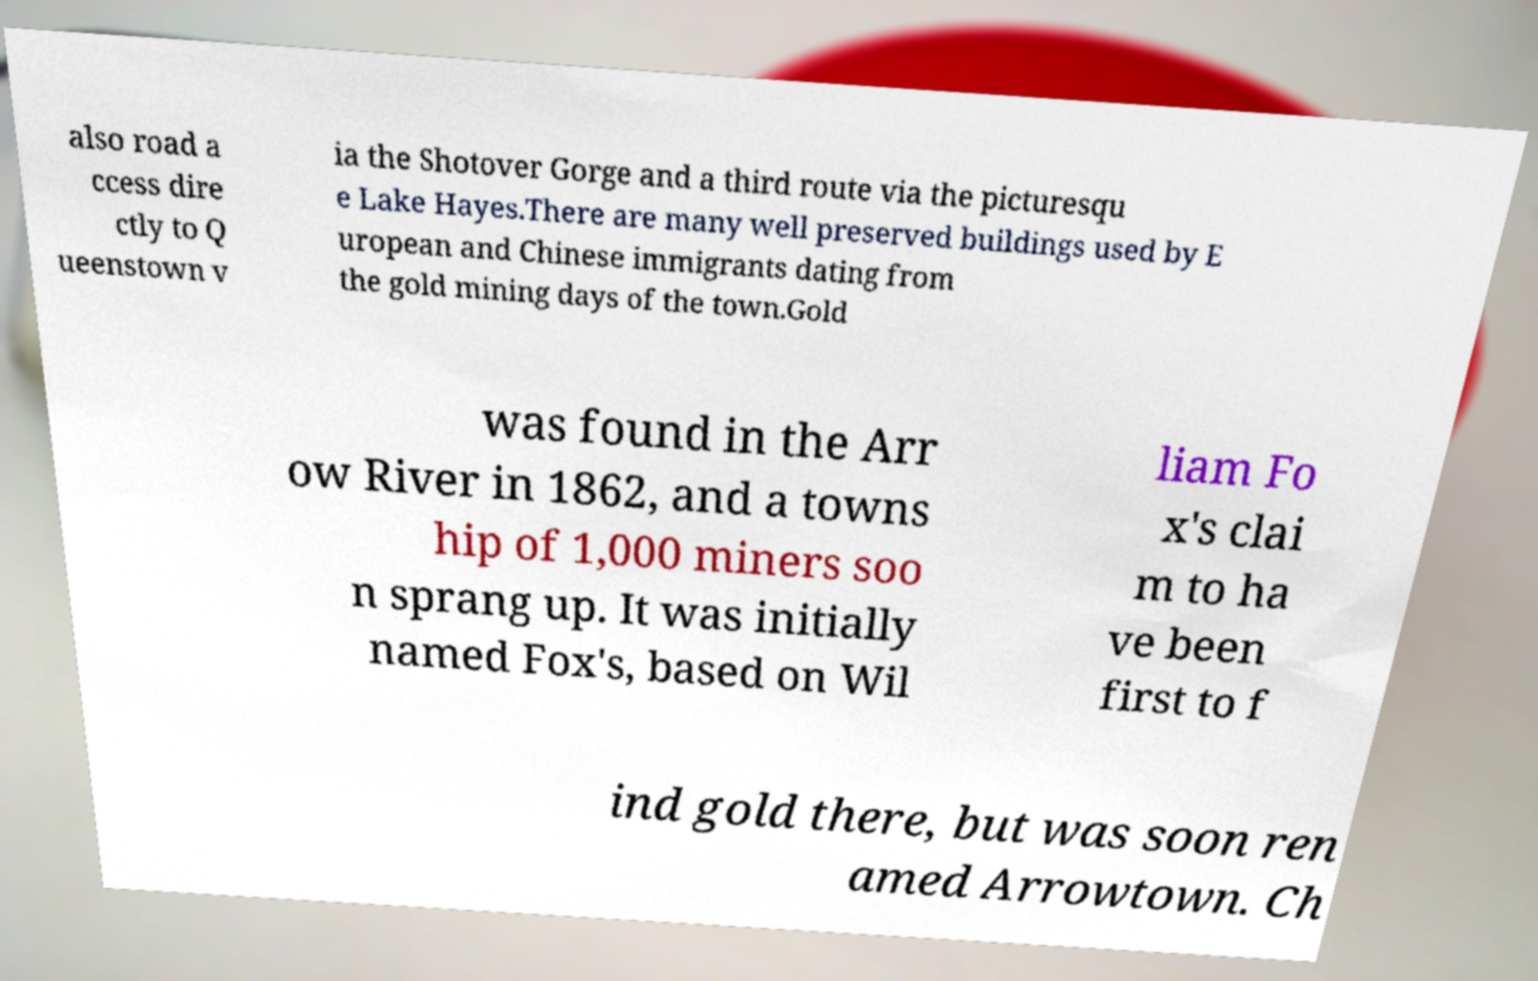Please read and relay the text visible in this image. What does it say? also road a ccess dire ctly to Q ueenstown v ia the Shotover Gorge and a third route via the picturesqu e Lake Hayes.There are many well preserved buildings used by E uropean and Chinese immigrants dating from the gold mining days of the town.Gold was found in the Arr ow River in 1862, and a towns hip of 1,000 miners soo n sprang up. It was initially named Fox's, based on Wil liam Fo x's clai m to ha ve been first to f ind gold there, but was soon ren amed Arrowtown. Ch 